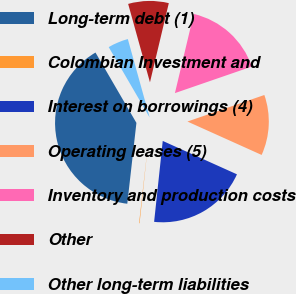Convert chart to OTSL. <chart><loc_0><loc_0><loc_500><loc_500><pie_chart><fcel>Long-term debt (1)<fcel>Colombian Investment and<fcel>Interest on borrowings (4)<fcel>Operating leases (5)<fcel>Inventory and production costs<fcel>Other<fcel>Other long-term liabilities<nl><fcel>39.82%<fcel>0.1%<fcel>19.96%<fcel>12.02%<fcel>15.99%<fcel>8.04%<fcel>4.07%<nl></chart> 